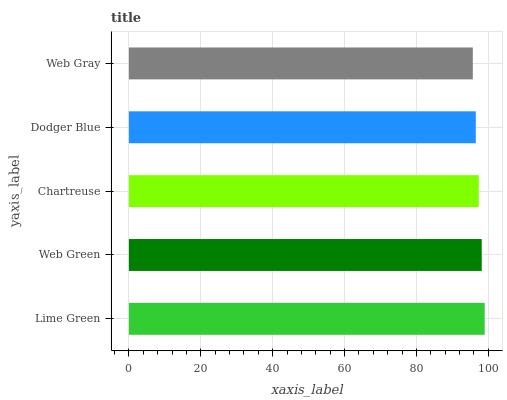Is Web Gray the minimum?
Answer yes or no. Yes. Is Lime Green the maximum?
Answer yes or no. Yes. Is Web Green the minimum?
Answer yes or no. No. Is Web Green the maximum?
Answer yes or no. No. Is Lime Green greater than Web Green?
Answer yes or no. Yes. Is Web Green less than Lime Green?
Answer yes or no. Yes. Is Web Green greater than Lime Green?
Answer yes or no. No. Is Lime Green less than Web Green?
Answer yes or no. No. Is Chartreuse the high median?
Answer yes or no. Yes. Is Chartreuse the low median?
Answer yes or no. Yes. Is Web Gray the high median?
Answer yes or no. No. Is Web Gray the low median?
Answer yes or no. No. 